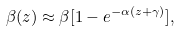Convert formula to latex. <formula><loc_0><loc_0><loc_500><loc_500>\beta ( z ) \approx \beta [ 1 - e ^ { - \alpha ( z + \gamma ) } ] ,</formula> 